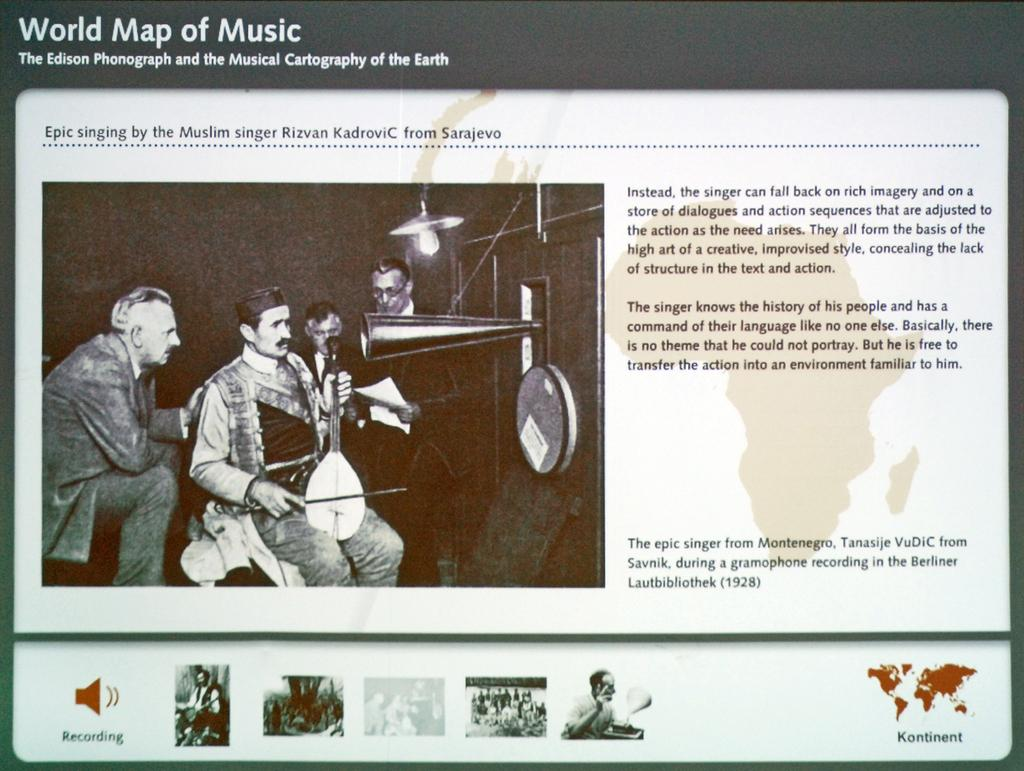What is the main subject of the image? The main subject of the image is a presentation slide. What is depicted on the slide? The slide contains a group of people. What are some of the people in the group doing? Some people in the group are playing musical instruments. What type of bear can be seen impulsively going on vacation in the image? There is no bear or vacation depicted in the image; it features a presentation slide with a group of people, some of whom are playing musical instruments. 